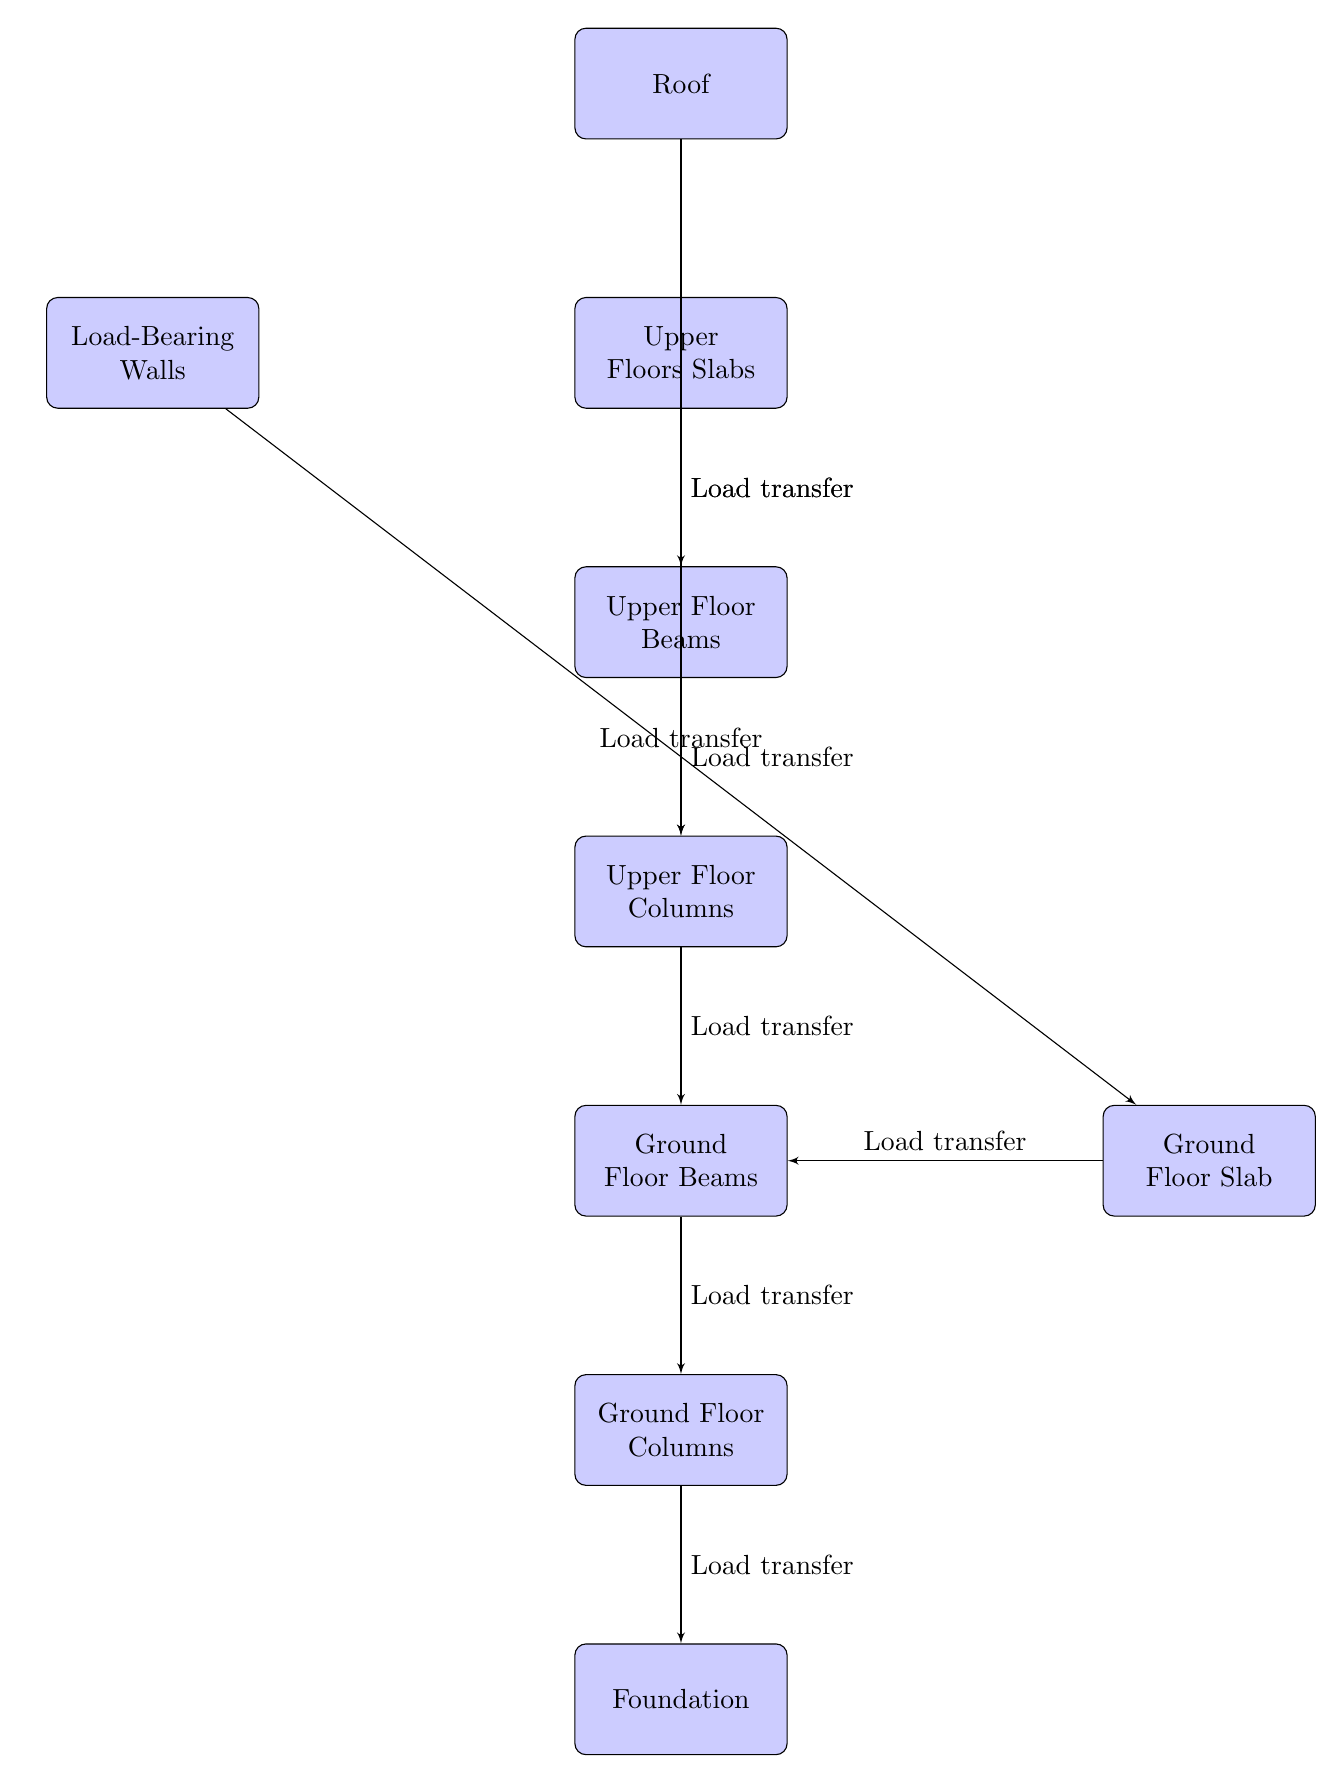What is the highest node in the diagram? The diagram shows the various components of structural load distribution, with the roof placed at the top. Therefore, the highest node is the Roof.
Answer: Roof How many load transfer connections are depicted in the diagram? By counting the arrows or edges connecting the nodes, we observe a total of 7 load transfer connections in the diagram.
Answer: 7 What is the function of the ground column in the load distribution? The ground column serves as a critical component in transferring loads from the ground beams below it to the foundation beneath.
Answer: Load transfer Which node directly supports the roof according to the diagram? The roof's load transfer path leads directly downwards to the upper floor columns, making them the direct supporters of the roof.
Answer: Upper Floor Columns What element does the load-bearing wall interact with in the load path? According to the diagram, the load-bearing wall interacts with the ground slab, as indicated by the load transfer connection between them.
Answer: Ground Floor Slab What is the lowest structural component shown in the diagram? The foundation is the lowest structural component that is visually presented at the bottom of the diagram, serving as the base for the entire structure.
Answer: Foundation Which component is positioned to the left of the upper slab? The diagram indicates that the load-bearing wall is situated to the left of the upper slab.
Answer: Load-Bearing Walls What is the primary purpose of the ground floor beams in the structural load path? Ground floor beams primarily facilitate the transfer of loads from the ground columns to the foundation, ensuring structural integrity.
Answer: Load transfer 